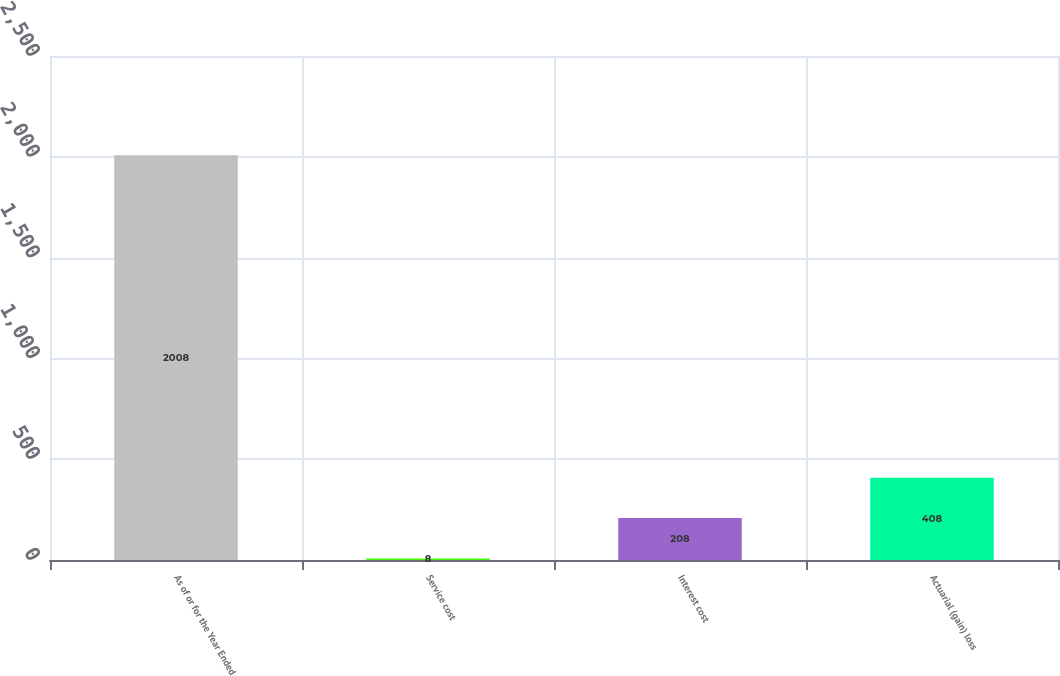<chart> <loc_0><loc_0><loc_500><loc_500><bar_chart><fcel>As of or for the Year Ended<fcel>Service cost<fcel>Interest cost<fcel>Actuarial (gain) loss<nl><fcel>2008<fcel>8<fcel>208<fcel>408<nl></chart> 